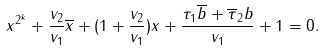Convert formula to latex. <formula><loc_0><loc_0><loc_500><loc_500>x ^ { 2 ^ { k } } + \frac { v _ { 2 } } { v _ { 1 } } \overline { x } + ( 1 + \frac { v _ { 2 } } { v _ { 1 } } ) x + \frac { \tau _ { 1 } \overline { b } + \overline { \tau } _ { 2 } b } { v _ { 1 } } + 1 = 0 .</formula> 